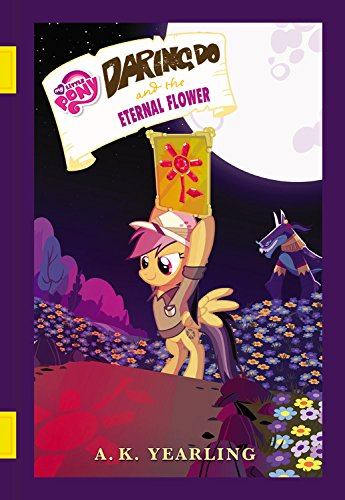What type of book is this? This is a children's book, specifically designed with colorful illustrations and engaging tales that cater to young readers. 